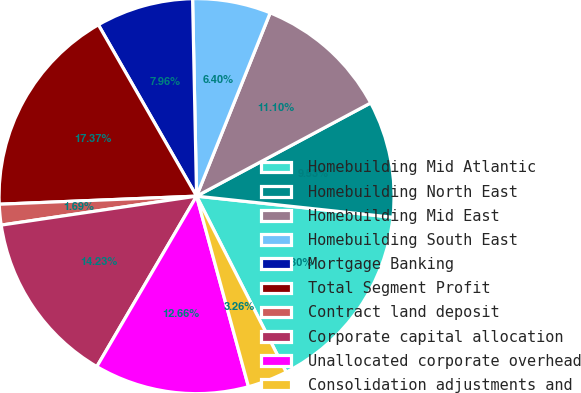<chart> <loc_0><loc_0><loc_500><loc_500><pie_chart><fcel>Homebuilding Mid Atlantic<fcel>Homebuilding North East<fcel>Homebuilding Mid East<fcel>Homebuilding South East<fcel>Mortgage Banking<fcel>Total Segment Profit<fcel>Contract land deposit<fcel>Corporate capital allocation<fcel>Unallocated corporate overhead<fcel>Consolidation adjustments and<nl><fcel>15.8%<fcel>9.53%<fcel>11.1%<fcel>6.4%<fcel>7.96%<fcel>17.37%<fcel>1.69%<fcel>14.23%<fcel>12.66%<fcel>3.26%<nl></chart> 